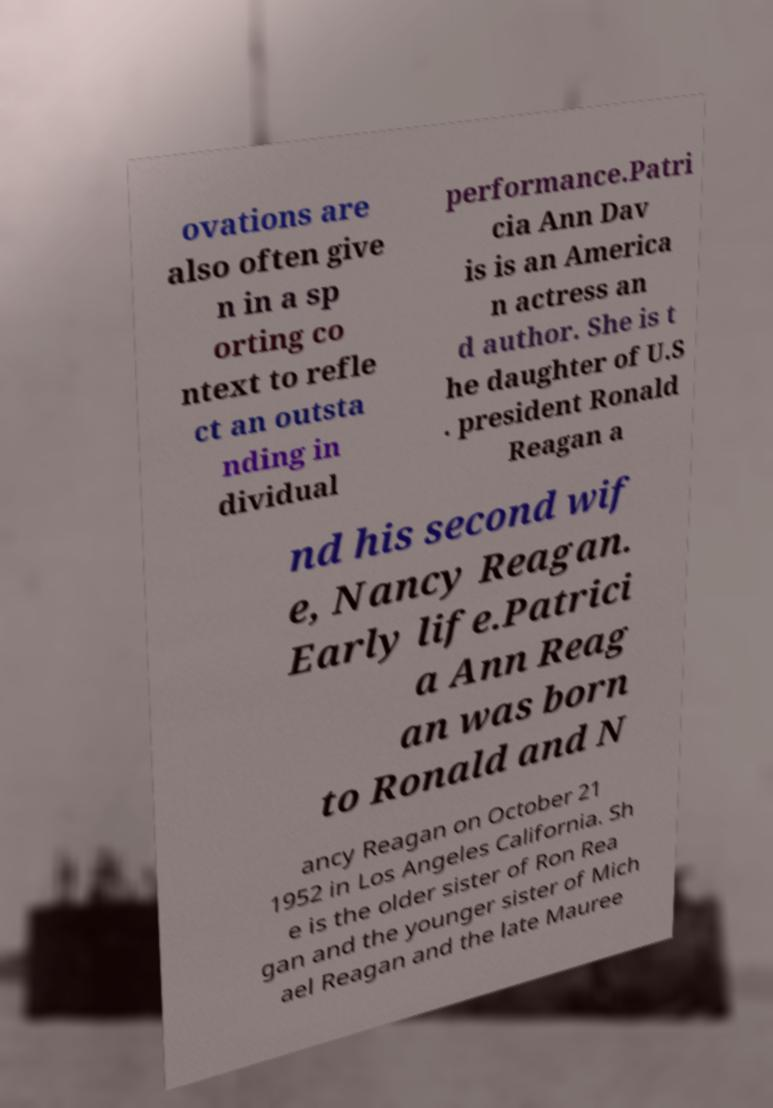Can you accurately transcribe the text from the provided image for me? ovations are also often give n in a sp orting co ntext to refle ct an outsta nding in dividual performance.Patri cia Ann Dav is is an America n actress an d author. She is t he daughter of U.S . president Ronald Reagan a nd his second wif e, Nancy Reagan. Early life.Patrici a Ann Reag an was born to Ronald and N ancy Reagan on October 21 1952 in Los Angeles California. Sh e is the older sister of Ron Rea gan and the younger sister of Mich ael Reagan and the late Mauree 